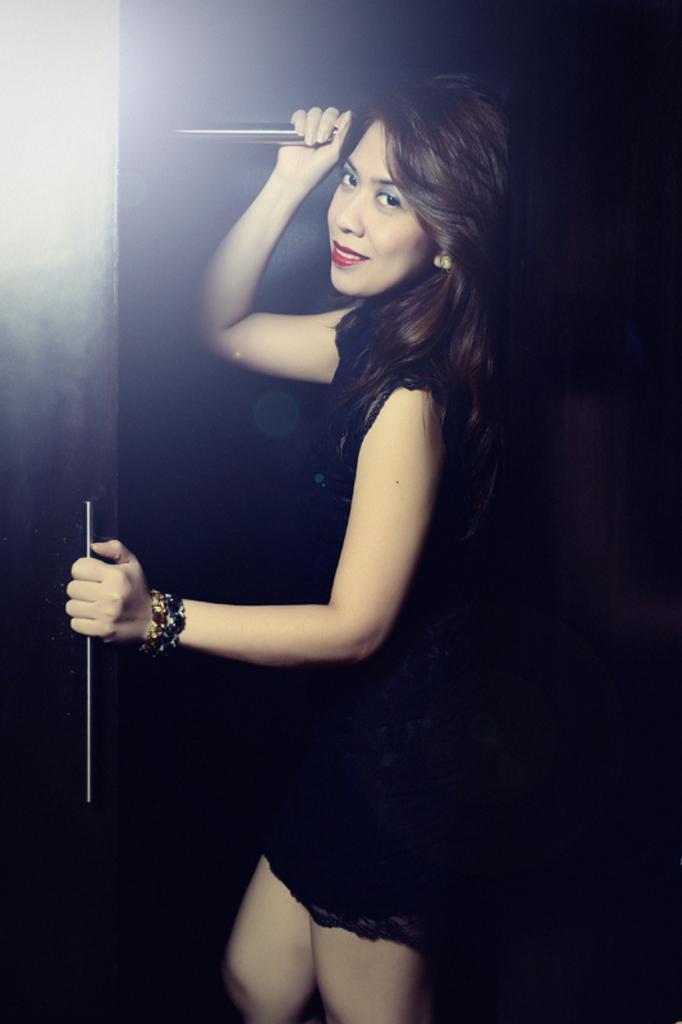How would you summarize this image in a sentence or two? In this image we can see a woman. She is wearing black color dress and holding a door. 